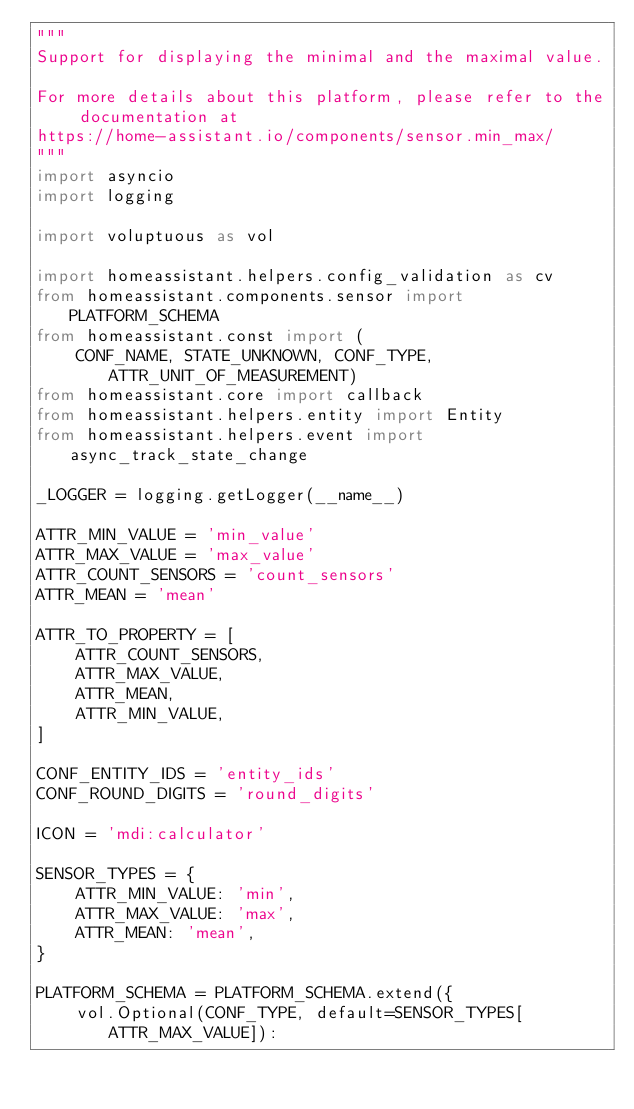Convert code to text. <code><loc_0><loc_0><loc_500><loc_500><_Python_>"""
Support for displaying the minimal and the maximal value.

For more details about this platform, please refer to the documentation at
https://home-assistant.io/components/sensor.min_max/
"""
import asyncio
import logging

import voluptuous as vol

import homeassistant.helpers.config_validation as cv
from homeassistant.components.sensor import PLATFORM_SCHEMA
from homeassistant.const import (
    CONF_NAME, STATE_UNKNOWN, CONF_TYPE, ATTR_UNIT_OF_MEASUREMENT)
from homeassistant.core import callback
from homeassistant.helpers.entity import Entity
from homeassistant.helpers.event import async_track_state_change

_LOGGER = logging.getLogger(__name__)

ATTR_MIN_VALUE = 'min_value'
ATTR_MAX_VALUE = 'max_value'
ATTR_COUNT_SENSORS = 'count_sensors'
ATTR_MEAN = 'mean'

ATTR_TO_PROPERTY = [
    ATTR_COUNT_SENSORS,
    ATTR_MAX_VALUE,
    ATTR_MEAN,
    ATTR_MIN_VALUE,
]

CONF_ENTITY_IDS = 'entity_ids'
CONF_ROUND_DIGITS = 'round_digits'

ICON = 'mdi:calculator'

SENSOR_TYPES = {
    ATTR_MIN_VALUE: 'min',
    ATTR_MAX_VALUE: 'max',
    ATTR_MEAN: 'mean',
}

PLATFORM_SCHEMA = PLATFORM_SCHEMA.extend({
    vol.Optional(CONF_TYPE, default=SENSOR_TYPES[ATTR_MAX_VALUE]):</code> 